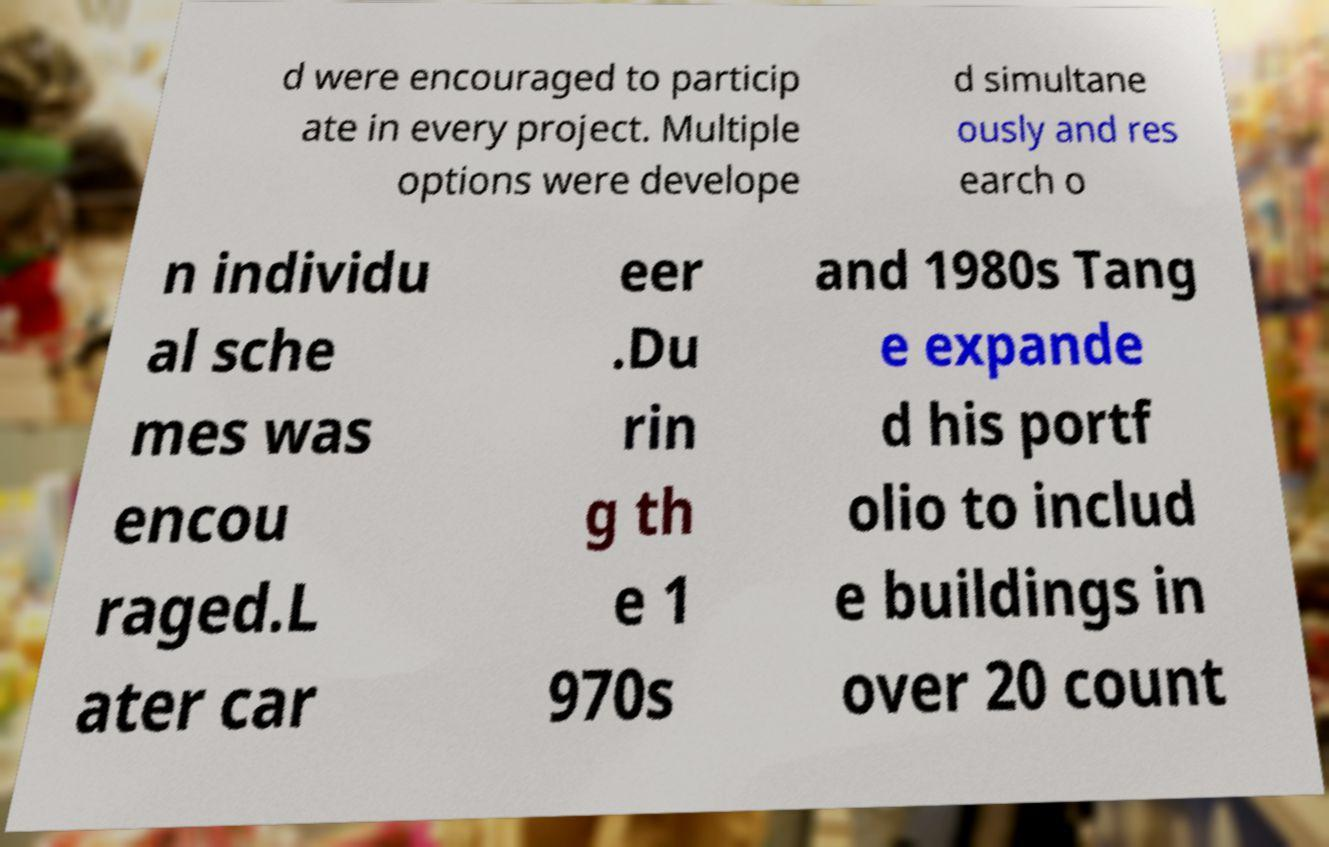Can you accurately transcribe the text from the provided image for me? d were encouraged to particip ate in every project. Multiple options were develope d simultane ously and res earch o n individu al sche mes was encou raged.L ater car eer .Du rin g th e 1 970s and 1980s Tang e expande d his portf olio to includ e buildings in over 20 count 